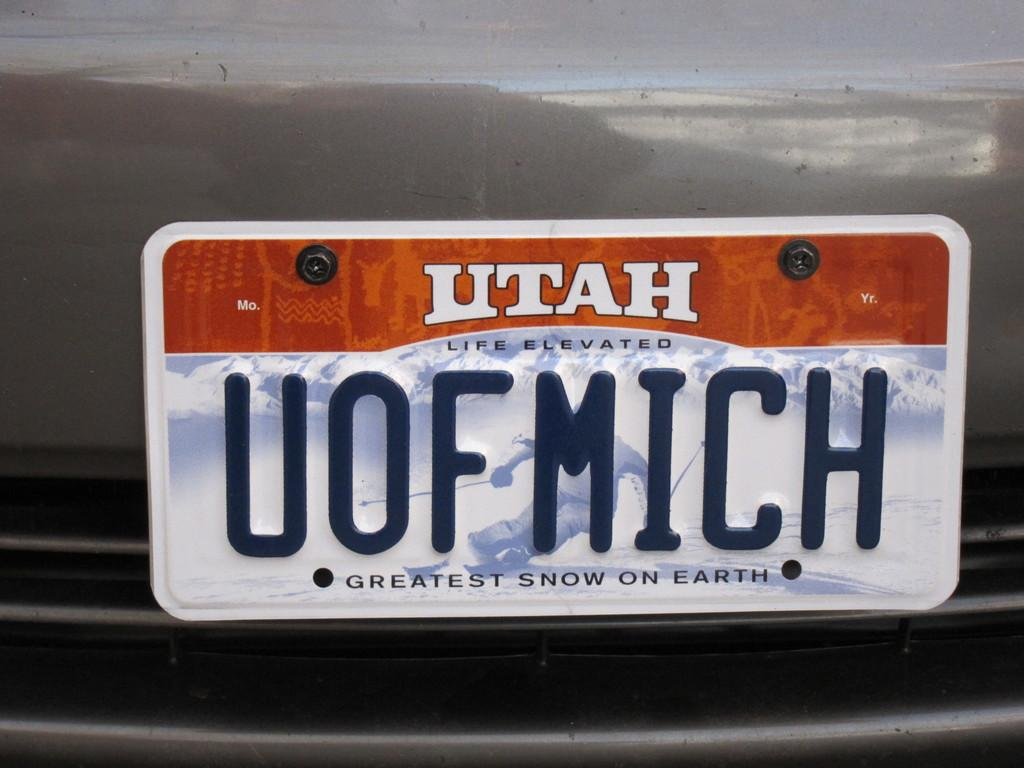<image>
Describe the image concisely. the word Utah that is on the back of a license plate 